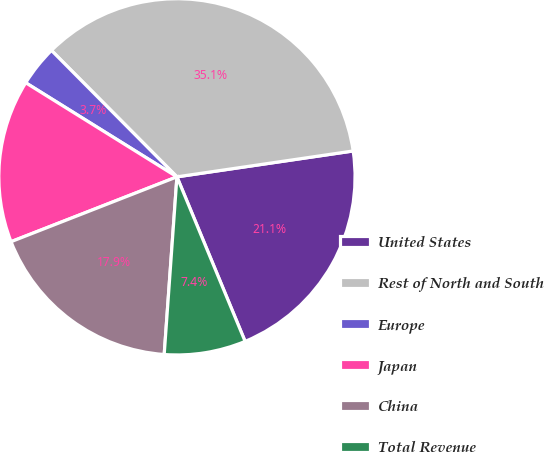Convert chart to OTSL. <chart><loc_0><loc_0><loc_500><loc_500><pie_chart><fcel>United States<fcel>Rest of North and South<fcel>Europe<fcel>Japan<fcel>China<fcel>Total Revenue<nl><fcel>21.07%<fcel>35.12%<fcel>3.7%<fcel>14.79%<fcel>17.93%<fcel>7.39%<nl></chart> 